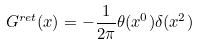<formula> <loc_0><loc_0><loc_500><loc_500>G ^ { r e t } ( x ) = - \frac { 1 } { 2 \pi } \theta ( x ^ { 0 } ) \delta ( x ^ { 2 } )</formula> 